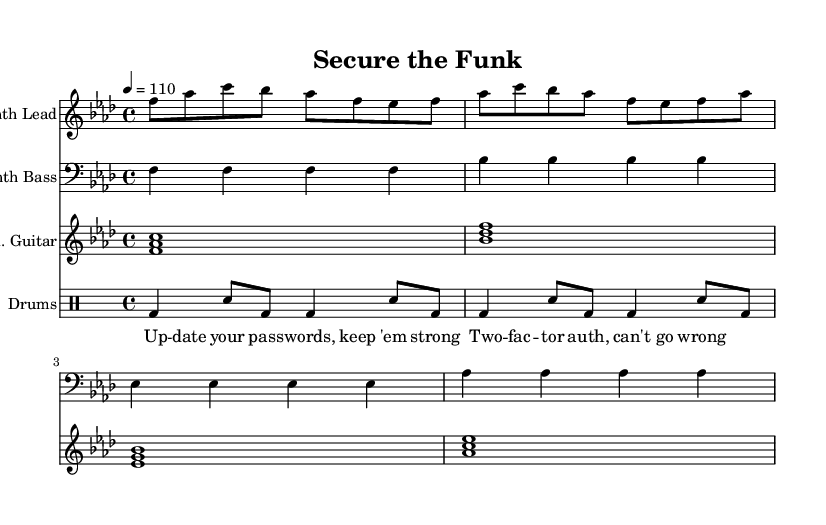What is the key signature of this music? The key signature is indicated by the sharps or flats at the beginning of the staff. In this case, there are four flats (B, E, A, D), meaning the key is F minor.
Answer: F minor What is the time signature of this music? The time signature is displayed as a fraction at the beginning of the staff. Here, it’s written as 4 over 4, indicating there are four beats in a measure and the quarter note gets one beat.
Answer: 4/4 What is the tempo marking for this piece? The tempo marking shows the speed of the music and is typically expressed in beats per minute. In this piece, it is indicated as 110, meaning 110 beats per minute.
Answer: 110 Which instrument is playing the synth lead? The instrument can be identified at the beginning of the staff where it lists the instrument name. Here it states "Synth Lead."
Answer: Synth Lead How many measures does the synth bass part have in this section? By counting the sequences of notes between the bar lines, you can identify the number of measures. The synth bass part consists of four distinct measures in the excerpt provided.
Answer: 4 What lyrical theme is evident in the lyrics? The lyrics focus specifically on cybersecurity practices, mentioning "passwords" and "two-factor authentication." These terms emphasize the theme of enhancing security.
Answer: Cybersecurity 